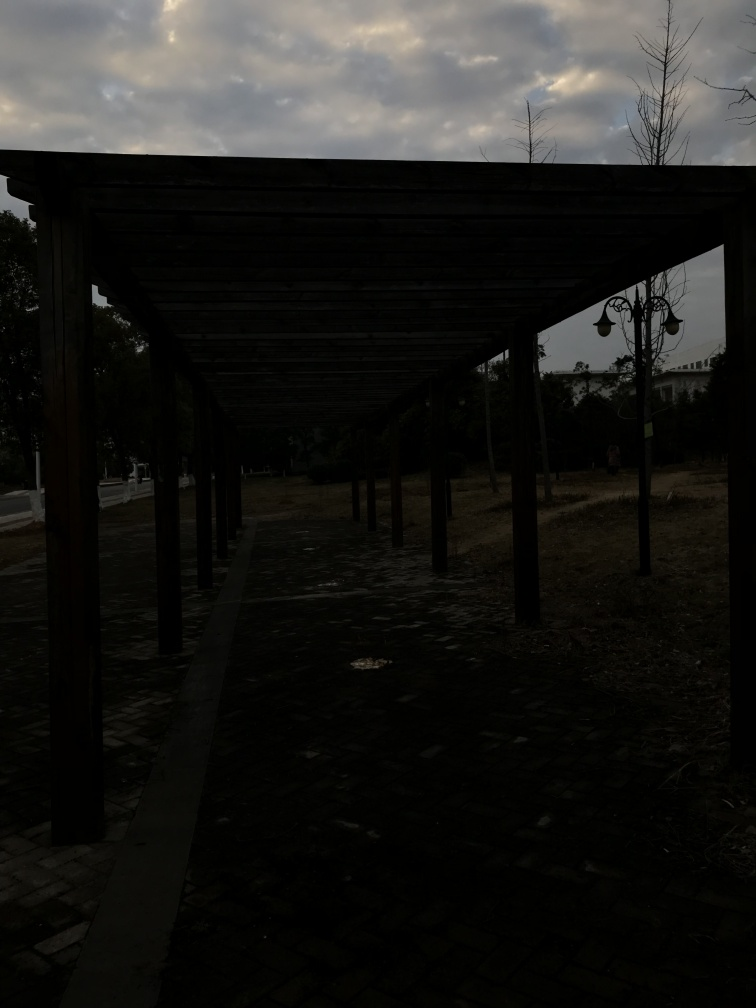Is the clarity of the image poor?
A. Yes
B. No
Answer with the option's letter from the given choices directly.
 A. 